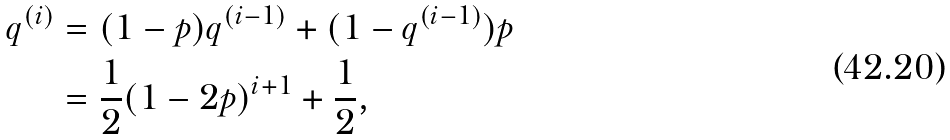Convert formula to latex. <formula><loc_0><loc_0><loc_500><loc_500>q ^ { ( i ) } & = ( 1 - p ) q ^ { ( i - 1 ) } + ( 1 - q ^ { ( i - 1 ) } ) p \\ & = \frac { 1 } { 2 } ( 1 - 2 p ) ^ { i + 1 } + \frac { 1 } { 2 } ,</formula> 